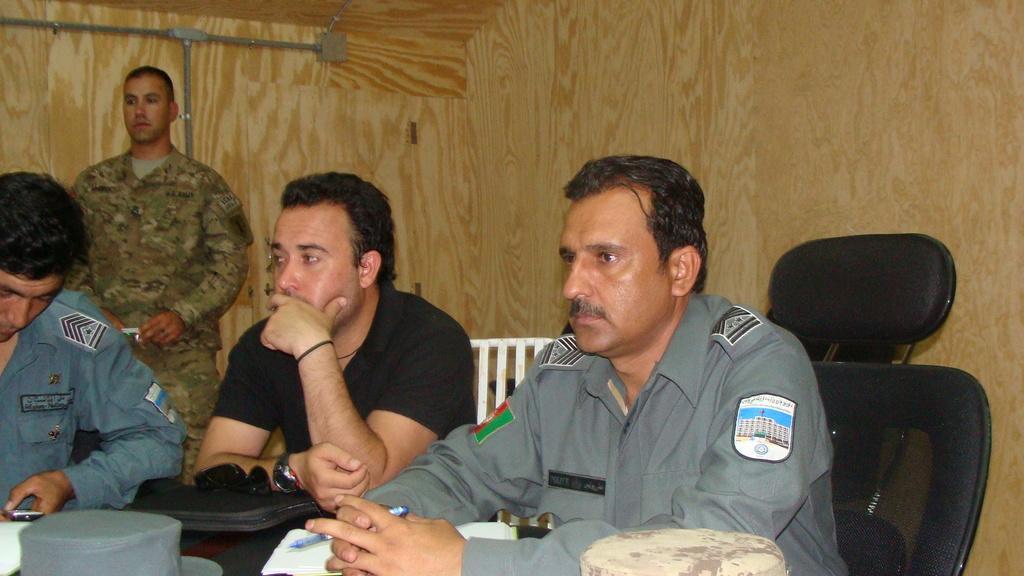Please provide a concise description of this image. In the foreground of this image, there are three men sitting on the chairs near table on which, there are books, hats, spectacles and an object. A man is holding a pen and another man is holding a mobile. In the background, there is a man standing and holding a camera and the wooden wall. 